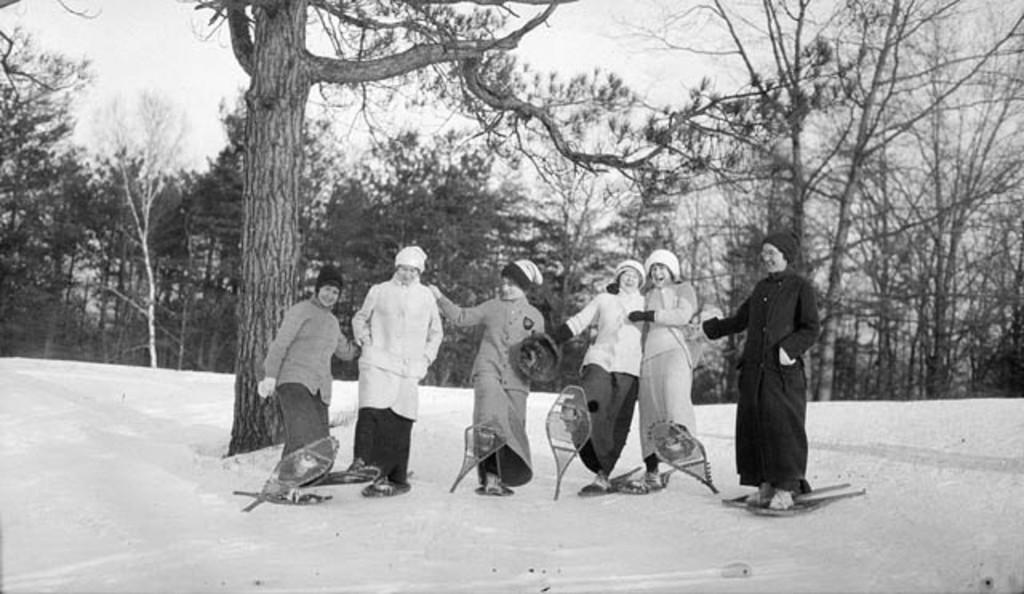How many women are in the image? There are 6 women in the image. What are the women doing in the image? The women are on ski boards. Where are the women located in the image? The women are on snow. What can be seen in the background of the image? There are trees in the background of the image. What type of belief system do the women in the image follow? There is no information about the women's belief system in the image. Can you see a stick in the image? There is no stick present in the image. 